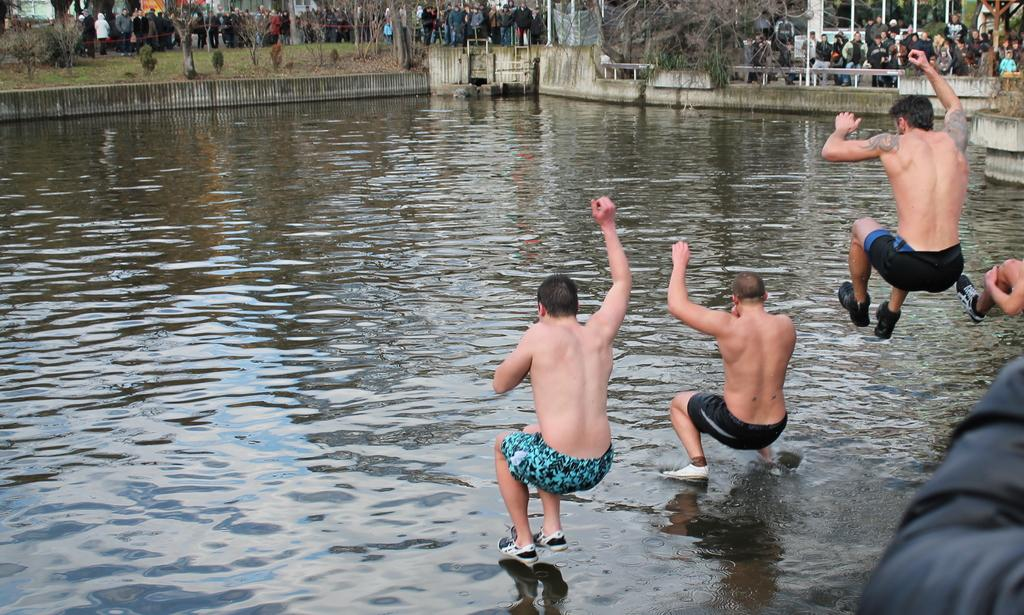How many people are in the image? There are four persons in the image. What are the persons in the image doing? The persons are jumping into a lake. What can be seen in the background of the image? There are trees and people in the background of the image. What type of machine is being used by the person with the longest toe in the image? There is no machine or mention of toes in the image; it features four persons jumping into a lake. 